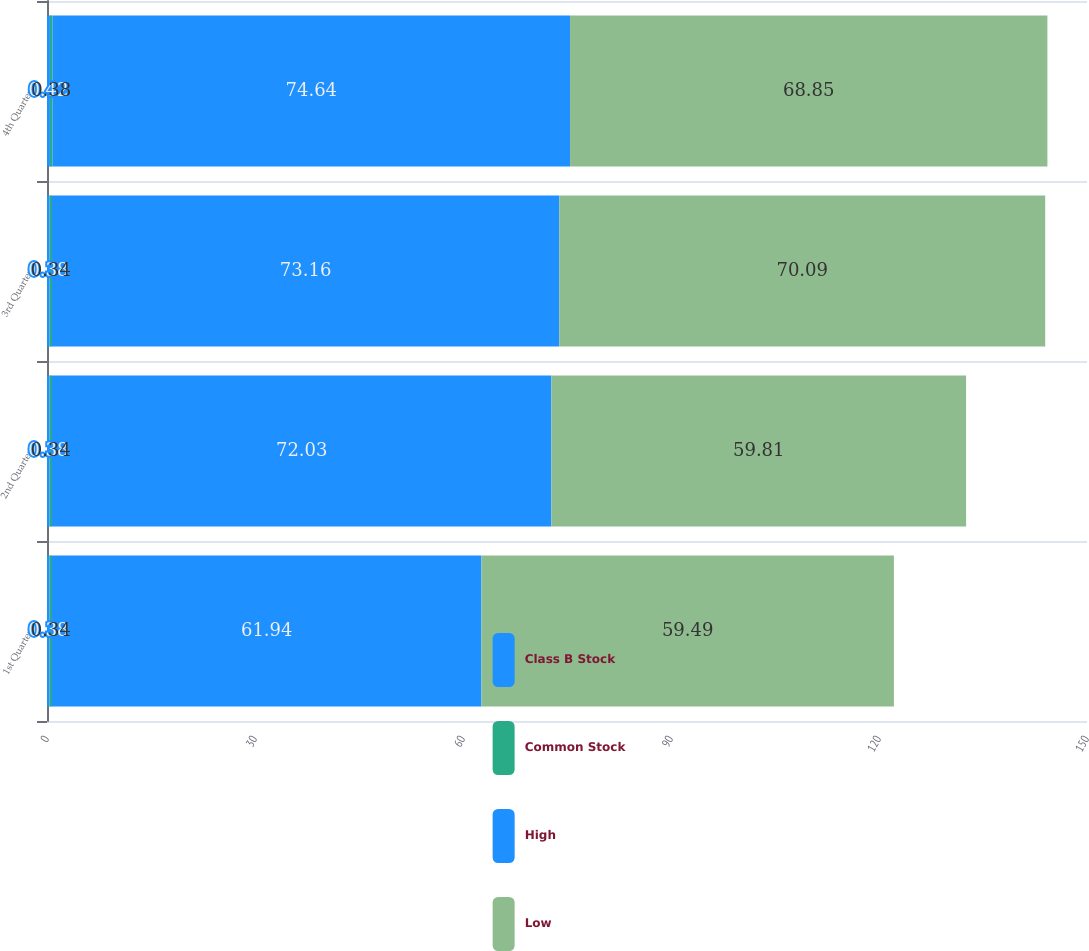Convert chart. <chart><loc_0><loc_0><loc_500><loc_500><stacked_bar_chart><ecel><fcel>1st Quarter<fcel>2nd Quarter<fcel>3rd Quarter<fcel>4th Quarter<nl><fcel>Class B Stock<fcel>0.38<fcel>0.38<fcel>0.38<fcel>0.42<nl><fcel>Common Stock<fcel>0.34<fcel>0.34<fcel>0.34<fcel>0.38<nl><fcel>High<fcel>61.94<fcel>72.03<fcel>73.16<fcel>74.64<nl><fcel>Low<fcel>59.49<fcel>59.81<fcel>70.09<fcel>68.85<nl></chart> 